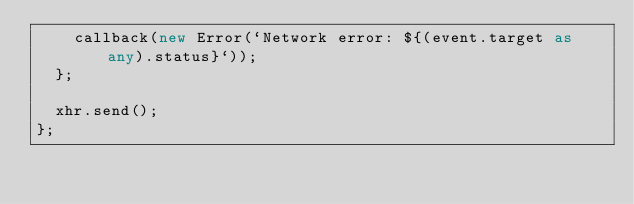<code> <loc_0><loc_0><loc_500><loc_500><_TypeScript_>    callback(new Error(`Network error: ${(event.target as any).status}`));
  };

  xhr.send();
};
</code> 